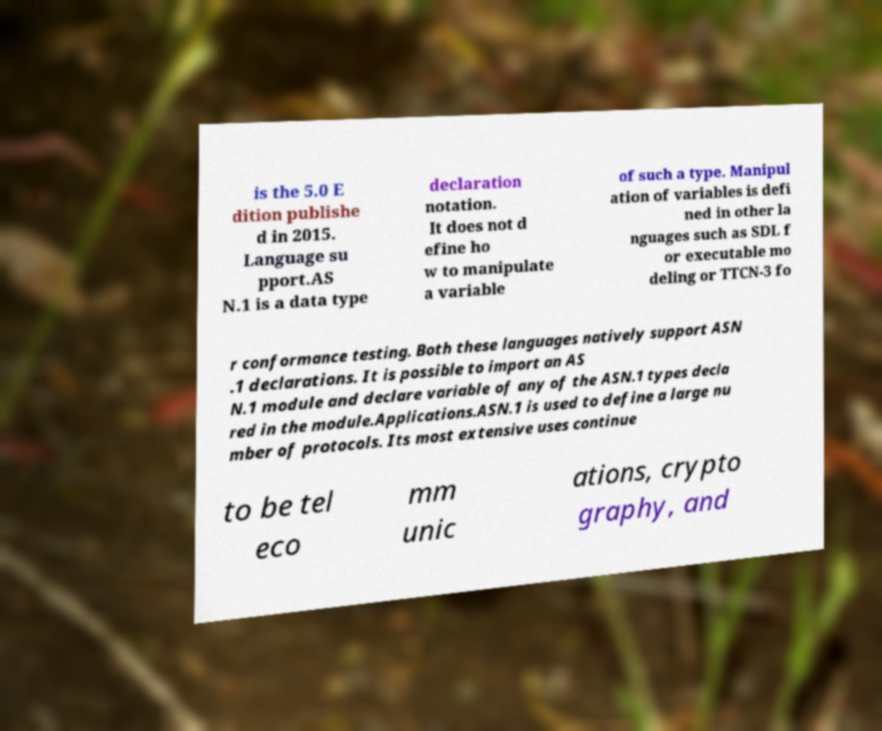What messages or text are displayed in this image? I need them in a readable, typed format. is the 5.0 E dition publishe d in 2015. Language su pport.AS N.1 is a data type declaration notation. It does not d efine ho w to manipulate a variable of such a type. Manipul ation of variables is defi ned in other la nguages such as SDL f or executable mo deling or TTCN-3 fo r conformance testing. Both these languages natively support ASN .1 declarations. It is possible to import an AS N.1 module and declare variable of any of the ASN.1 types decla red in the module.Applications.ASN.1 is used to define a large nu mber of protocols. Its most extensive uses continue to be tel eco mm unic ations, crypto graphy, and 